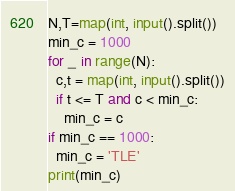Convert code to text. <code><loc_0><loc_0><loc_500><loc_500><_Python_>N,T=map(int, input().split())
min_c = 1000
for _ in range(N):
  c,t = map(int, input().split())
  if t <= T and c < min_c:
    min_c = c
if min_c == 1000:
  min_c = 'TLE'
print(min_c)</code> 